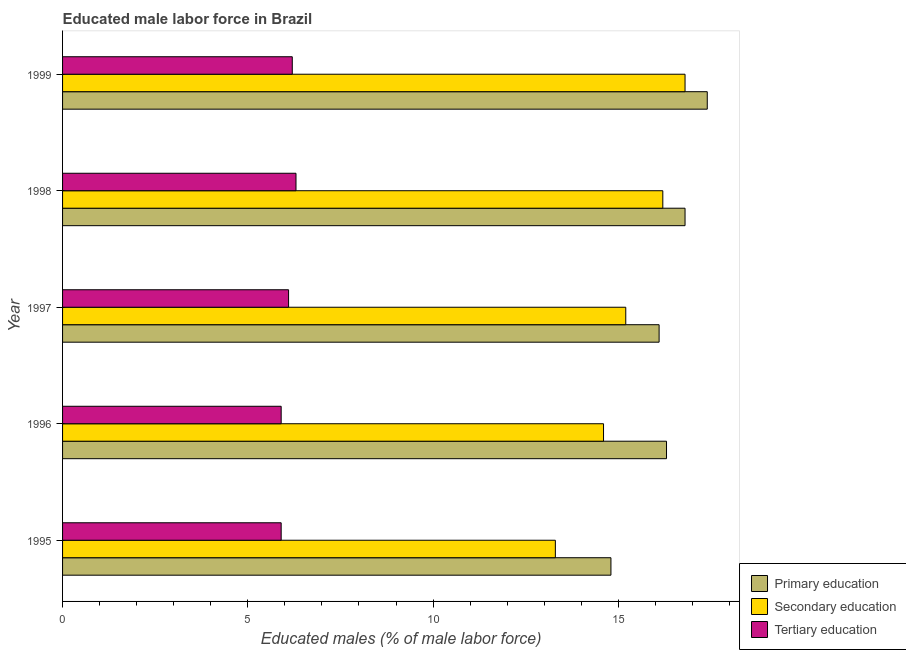How many different coloured bars are there?
Your response must be concise. 3. Are the number of bars on each tick of the Y-axis equal?
Your answer should be compact. Yes. How many bars are there on the 4th tick from the top?
Your answer should be very brief. 3. How many bars are there on the 3rd tick from the bottom?
Your response must be concise. 3. What is the label of the 1st group of bars from the top?
Ensure brevity in your answer.  1999. In how many cases, is the number of bars for a given year not equal to the number of legend labels?
Offer a very short reply. 0. What is the percentage of male labor force who received primary education in 1999?
Provide a succinct answer. 17.4. Across all years, what is the maximum percentage of male labor force who received secondary education?
Ensure brevity in your answer.  16.8. Across all years, what is the minimum percentage of male labor force who received secondary education?
Provide a short and direct response. 13.3. In which year was the percentage of male labor force who received secondary education maximum?
Your answer should be compact. 1999. In which year was the percentage of male labor force who received tertiary education minimum?
Ensure brevity in your answer.  1995. What is the total percentage of male labor force who received primary education in the graph?
Provide a short and direct response. 81.4. What is the difference between the percentage of male labor force who received tertiary education in 1997 and the percentage of male labor force who received primary education in 1998?
Your response must be concise. -10.7. What is the average percentage of male labor force who received secondary education per year?
Make the answer very short. 15.22. In how many years, is the percentage of male labor force who received primary education greater than 15 %?
Your answer should be compact. 4. What is the ratio of the percentage of male labor force who received primary education in 1997 to that in 1998?
Ensure brevity in your answer.  0.96. Is the percentage of male labor force who received primary education in 1995 less than that in 1997?
Give a very brief answer. Yes. Is the difference between the percentage of male labor force who received tertiary education in 1995 and 1998 greater than the difference between the percentage of male labor force who received secondary education in 1995 and 1998?
Offer a terse response. Yes. What is the difference between the highest and the lowest percentage of male labor force who received secondary education?
Your answer should be very brief. 3.5. Is the sum of the percentage of male labor force who received secondary education in 1997 and 1998 greater than the maximum percentage of male labor force who received primary education across all years?
Provide a short and direct response. Yes. What does the 1st bar from the top in 1998 represents?
Ensure brevity in your answer.  Tertiary education. What does the 1st bar from the bottom in 1997 represents?
Provide a short and direct response. Primary education. How many bars are there?
Your answer should be very brief. 15. How many years are there in the graph?
Keep it short and to the point. 5. Where does the legend appear in the graph?
Your answer should be very brief. Bottom right. How many legend labels are there?
Keep it short and to the point. 3. What is the title of the graph?
Offer a terse response. Educated male labor force in Brazil. Does "Consumption Tax" appear as one of the legend labels in the graph?
Provide a succinct answer. No. What is the label or title of the X-axis?
Make the answer very short. Educated males (% of male labor force). What is the Educated males (% of male labor force) of Primary education in 1995?
Offer a terse response. 14.8. What is the Educated males (% of male labor force) in Secondary education in 1995?
Provide a short and direct response. 13.3. What is the Educated males (% of male labor force) of Tertiary education in 1995?
Keep it short and to the point. 5.9. What is the Educated males (% of male labor force) in Primary education in 1996?
Offer a terse response. 16.3. What is the Educated males (% of male labor force) in Secondary education in 1996?
Offer a very short reply. 14.6. What is the Educated males (% of male labor force) in Tertiary education in 1996?
Offer a very short reply. 5.9. What is the Educated males (% of male labor force) of Primary education in 1997?
Provide a short and direct response. 16.1. What is the Educated males (% of male labor force) of Secondary education in 1997?
Your answer should be very brief. 15.2. What is the Educated males (% of male labor force) of Tertiary education in 1997?
Provide a short and direct response. 6.1. What is the Educated males (% of male labor force) of Primary education in 1998?
Ensure brevity in your answer.  16.8. What is the Educated males (% of male labor force) of Secondary education in 1998?
Your response must be concise. 16.2. What is the Educated males (% of male labor force) of Tertiary education in 1998?
Provide a succinct answer. 6.3. What is the Educated males (% of male labor force) of Primary education in 1999?
Offer a very short reply. 17.4. What is the Educated males (% of male labor force) in Secondary education in 1999?
Offer a very short reply. 16.8. What is the Educated males (% of male labor force) in Tertiary education in 1999?
Offer a terse response. 6.2. Across all years, what is the maximum Educated males (% of male labor force) of Primary education?
Ensure brevity in your answer.  17.4. Across all years, what is the maximum Educated males (% of male labor force) in Secondary education?
Make the answer very short. 16.8. Across all years, what is the maximum Educated males (% of male labor force) in Tertiary education?
Keep it short and to the point. 6.3. Across all years, what is the minimum Educated males (% of male labor force) in Primary education?
Give a very brief answer. 14.8. Across all years, what is the minimum Educated males (% of male labor force) of Secondary education?
Offer a terse response. 13.3. Across all years, what is the minimum Educated males (% of male labor force) of Tertiary education?
Give a very brief answer. 5.9. What is the total Educated males (% of male labor force) of Primary education in the graph?
Your answer should be compact. 81.4. What is the total Educated males (% of male labor force) in Secondary education in the graph?
Your answer should be compact. 76.1. What is the total Educated males (% of male labor force) in Tertiary education in the graph?
Provide a short and direct response. 30.4. What is the difference between the Educated males (% of male labor force) of Primary education in 1995 and that in 1997?
Make the answer very short. -1.3. What is the difference between the Educated males (% of male labor force) of Tertiary education in 1995 and that in 1997?
Make the answer very short. -0.2. What is the difference between the Educated males (% of male labor force) of Primary education in 1995 and that in 1998?
Provide a succinct answer. -2. What is the difference between the Educated males (% of male labor force) in Secondary education in 1995 and that in 1998?
Provide a succinct answer. -2.9. What is the difference between the Educated males (% of male labor force) in Tertiary education in 1995 and that in 1998?
Provide a short and direct response. -0.4. What is the difference between the Educated males (% of male labor force) of Primary education in 1995 and that in 1999?
Ensure brevity in your answer.  -2.6. What is the difference between the Educated males (% of male labor force) in Primary education in 1996 and that in 1997?
Ensure brevity in your answer.  0.2. What is the difference between the Educated males (% of male labor force) in Secondary education in 1996 and that in 1998?
Give a very brief answer. -1.6. What is the difference between the Educated males (% of male labor force) of Secondary education in 1996 and that in 1999?
Give a very brief answer. -2.2. What is the difference between the Educated males (% of male labor force) in Secondary education in 1997 and that in 1998?
Give a very brief answer. -1. What is the difference between the Educated males (% of male labor force) of Primary education in 1997 and that in 1999?
Offer a very short reply. -1.3. What is the difference between the Educated males (% of male labor force) of Primary education in 1998 and that in 1999?
Provide a succinct answer. -0.6. What is the difference between the Educated males (% of male labor force) of Secondary education in 1998 and that in 1999?
Ensure brevity in your answer.  -0.6. What is the difference between the Educated males (% of male labor force) of Primary education in 1995 and the Educated males (% of male labor force) of Secondary education in 1996?
Your answer should be compact. 0.2. What is the difference between the Educated males (% of male labor force) of Primary education in 1995 and the Educated males (% of male labor force) of Tertiary education in 1996?
Provide a short and direct response. 8.9. What is the difference between the Educated males (% of male labor force) of Primary education in 1995 and the Educated males (% of male labor force) of Tertiary education in 1998?
Provide a succinct answer. 8.5. What is the difference between the Educated males (% of male labor force) in Primary education in 1995 and the Educated males (% of male labor force) in Tertiary education in 1999?
Provide a short and direct response. 8.6. What is the difference between the Educated males (% of male labor force) in Secondary education in 1995 and the Educated males (% of male labor force) in Tertiary education in 1999?
Give a very brief answer. 7.1. What is the difference between the Educated males (% of male labor force) in Primary education in 1996 and the Educated males (% of male labor force) in Secondary education in 1997?
Keep it short and to the point. 1.1. What is the difference between the Educated males (% of male labor force) in Primary education in 1996 and the Educated males (% of male labor force) in Tertiary education in 1997?
Your answer should be compact. 10.2. What is the difference between the Educated males (% of male labor force) of Secondary education in 1996 and the Educated males (% of male labor force) of Tertiary education in 1997?
Your response must be concise. 8.5. What is the difference between the Educated males (% of male labor force) of Primary education in 1996 and the Educated males (% of male labor force) of Secondary education in 1998?
Offer a very short reply. 0.1. What is the difference between the Educated males (% of male labor force) of Primary education in 1996 and the Educated males (% of male labor force) of Tertiary education in 1998?
Provide a short and direct response. 10. What is the difference between the Educated males (% of male labor force) in Secondary education in 1996 and the Educated males (% of male labor force) in Tertiary education in 1998?
Provide a succinct answer. 8.3. What is the difference between the Educated males (% of male labor force) in Primary education in 1996 and the Educated males (% of male labor force) in Tertiary education in 1999?
Make the answer very short. 10.1. What is the difference between the Educated males (% of male labor force) of Primary education in 1997 and the Educated males (% of male labor force) of Secondary education in 1998?
Your answer should be compact. -0.1. What is the difference between the Educated males (% of male labor force) of Primary education in 1997 and the Educated males (% of male labor force) of Tertiary education in 1998?
Provide a succinct answer. 9.8. What is the difference between the Educated males (% of male labor force) of Secondary education in 1997 and the Educated males (% of male labor force) of Tertiary education in 1998?
Offer a terse response. 8.9. What is the difference between the Educated males (% of male labor force) of Primary education in 1997 and the Educated males (% of male labor force) of Secondary education in 1999?
Give a very brief answer. -0.7. What is the difference between the Educated males (% of male labor force) in Primary education in 1998 and the Educated males (% of male labor force) in Tertiary education in 1999?
Your answer should be compact. 10.6. What is the average Educated males (% of male labor force) in Primary education per year?
Your response must be concise. 16.28. What is the average Educated males (% of male labor force) of Secondary education per year?
Give a very brief answer. 15.22. What is the average Educated males (% of male labor force) in Tertiary education per year?
Your answer should be compact. 6.08. In the year 1995, what is the difference between the Educated males (% of male labor force) in Primary education and Educated males (% of male labor force) in Secondary education?
Your answer should be very brief. 1.5. In the year 1996, what is the difference between the Educated males (% of male labor force) in Primary education and Educated males (% of male labor force) in Secondary education?
Keep it short and to the point. 1.7. In the year 1996, what is the difference between the Educated males (% of male labor force) of Primary education and Educated males (% of male labor force) of Tertiary education?
Make the answer very short. 10.4. In the year 1996, what is the difference between the Educated males (% of male labor force) of Secondary education and Educated males (% of male labor force) of Tertiary education?
Your response must be concise. 8.7. In the year 1997, what is the difference between the Educated males (% of male labor force) in Secondary education and Educated males (% of male labor force) in Tertiary education?
Ensure brevity in your answer.  9.1. In the year 1999, what is the difference between the Educated males (% of male labor force) of Primary education and Educated males (% of male labor force) of Secondary education?
Offer a terse response. 0.6. In the year 1999, what is the difference between the Educated males (% of male labor force) of Primary education and Educated males (% of male labor force) of Tertiary education?
Your answer should be very brief. 11.2. What is the ratio of the Educated males (% of male labor force) of Primary education in 1995 to that in 1996?
Provide a succinct answer. 0.91. What is the ratio of the Educated males (% of male labor force) of Secondary education in 1995 to that in 1996?
Offer a very short reply. 0.91. What is the ratio of the Educated males (% of male labor force) of Primary education in 1995 to that in 1997?
Offer a terse response. 0.92. What is the ratio of the Educated males (% of male labor force) of Tertiary education in 1995 to that in 1997?
Make the answer very short. 0.97. What is the ratio of the Educated males (% of male labor force) of Primary education in 1995 to that in 1998?
Ensure brevity in your answer.  0.88. What is the ratio of the Educated males (% of male labor force) in Secondary education in 1995 to that in 1998?
Make the answer very short. 0.82. What is the ratio of the Educated males (% of male labor force) of Tertiary education in 1995 to that in 1998?
Offer a terse response. 0.94. What is the ratio of the Educated males (% of male labor force) of Primary education in 1995 to that in 1999?
Ensure brevity in your answer.  0.85. What is the ratio of the Educated males (% of male labor force) of Secondary education in 1995 to that in 1999?
Provide a succinct answer. 0.79. What is the ratio of the Educated males (% of male labor force) of Tertiary education in 1995 to that in 1999?
Ensure brevity in your answer.  0.95. What is the ratio of the Educated males (% of male labor force) in Primary education in 1996 to that in 1997?
Your response must be concise. 1.01. What is the ratio of the Educated males (% of male labor force) of Secondary education in 1996 to that in 1997?
Ensure brevity in your answer.  0.96. What is the ratio of the Educated males (% of male labor force) of Tertiary education in 1996 to that in 1997?
Offer a terse response. 0.97. What is the ratio of the Educated males (% of male labor force) in Primary education in 1996 to that in 1998?
Your response must be concise. 0.97. What is the ratio of the Educated males (% of male labor force) of Secondary education in 1996 to that in 1998?
Your response must be concise. 0.9. What is the ratio of the Educated males (% of male labor force) of Tertiary education in 1996 to that in 1998?
Offer a terse response. 0.94. What is the ratio of the Educated males (% of male labor force) of Primary education in 1996 to that in 1999?
Your answer should be very brief. 0.94. What is the ratio of the Educated males (% of male labor force) of Secondary education in 1996 to that in 1999?
Provide a succinct answer. 0.87. What is the ratio of the Educated males (% of male labor force) in Tertiary education in 1996 to that in 1999?
Offer a very short reply. 0.95. What is the ratio of the Educated males (% of male labor force) of Secondary education in 1997 to that in 1998?
Offer a very short reply. 0.94. What is the ratio of the Educated males (% of male labor force) of Tertiary education in 1997 to that in 1998?
Your response must be concise. 0.97. What is the ratio of the Educated males (% of male labor force) in Primary education in 1997 to that in 1999?
Provide a short and direct response. 0.93. What is the ratio of the Educated males (% of male labor force) in Secondary education in 1997 to that in 1999?
Keep it short and to the point. 0.9. What is the ratio of the Educated males (% of male labor force) of Tertiary education in 1997 to that in 1999?
Offer a very short reply. 0.98. What is the ratio of the Educated males (% of male labor force) of Primary education in 1998 to that in 1999?
Provide a short and direct response. 0.97. What is the ratio of the Educated males (% of male labor force) of Tertiary education in 1998 to that in 1999?
Your answer should be compact. 1.02. What is the difference between the highest and the second highest Educated males (% of male labor force) in Primary education?
Your answer should be compact. 0.6. What is the difference between the highest and the second highest Educated males (% of male labor force) of Tertiary education?
Make the answer very short. 0.1. What is the difference between the highest and the lowest Educated males (% of male labor force) in Primary education?
Your response must be concise. 2.6. What is the difference between the highest and the lowest Educated males (% of male labor force) of Tertiary education?
Offer a terse response. 0.4. 